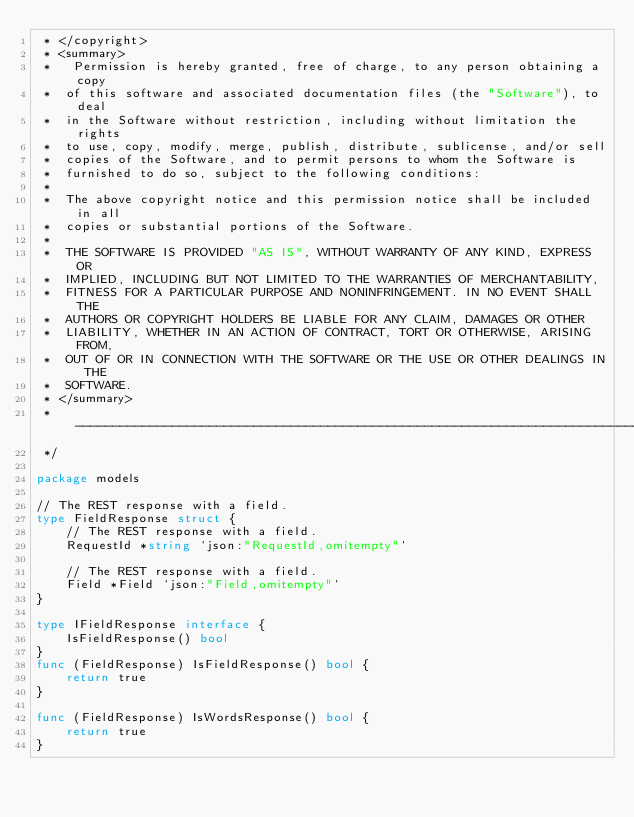<code> <loc_0><loc_0><loc_500><loc_500><_Go_> * </copyright>
 * <summary>
 *   Permission is hereby granted, free of charge, to any person obtaining a copy
 *  of this software and associated documentation files (the "Software"), to deal
 *  in the Software without restriction, including without limitation the rights
 *  to use, copy, modify, merge, publish, distribute, sublicense, and/or sell
 *  copies of the Software, and to permit persons to whom the Software is
 *  furnished to do so, subject to the following conditions:
 * 
 *  The above copyright notice and this permission notice shall be included in all
 *  copies or substantial portions of the Software.
 * 
 *  THE SOFTWARE IS PROVIDED "AS IS", WITHOUT WARRANTY OF ANY KIND, EXPRESS OR
 *  IMPLIED, INCLUDING BUT NOT LIMITED TO THE WARRANTIES OF MERCHANTABILITY,
 *  FITNESS FOR A PARTICULAR PURPOSE AND NONINFRINGEMENT. IN NO EVENT SHALL THE
 *  AUTHORS OR COPYRIGHT HOLDERS BE LIABLE FOR ANY CLAIM, DAMAGES OR OTHER
 *  LIABILITY, WHETHER IN AN ACTION OF CONTRACT, TORT OR OTHERWISE, ARISING FROM,
 *  OUT OF OR IN CONNECTION WITH THE SOFTWARE OR THE USE OR OTHER DEALINGS IN THE
 *  SOFTWARE.
 * </summary>
 * --------------------------------------------------------------------------------
 */

package models

// The REST response with a field.
type FieldResponse struct {
    // The REST response with a field.
    RequestId *string `json:"RequestId,omitempty"`

    // The REST response with a field.
    Field *Field `json:"Field,omitempty"`
}

type IFieldResponse interface {
    IsFieldResponse() bool
}
func (FieldResponse) IsFieldResponse() bool {
    return true
}

func (FieldResponse) IsWordsResponse() bool {
    return true
}
</code> 